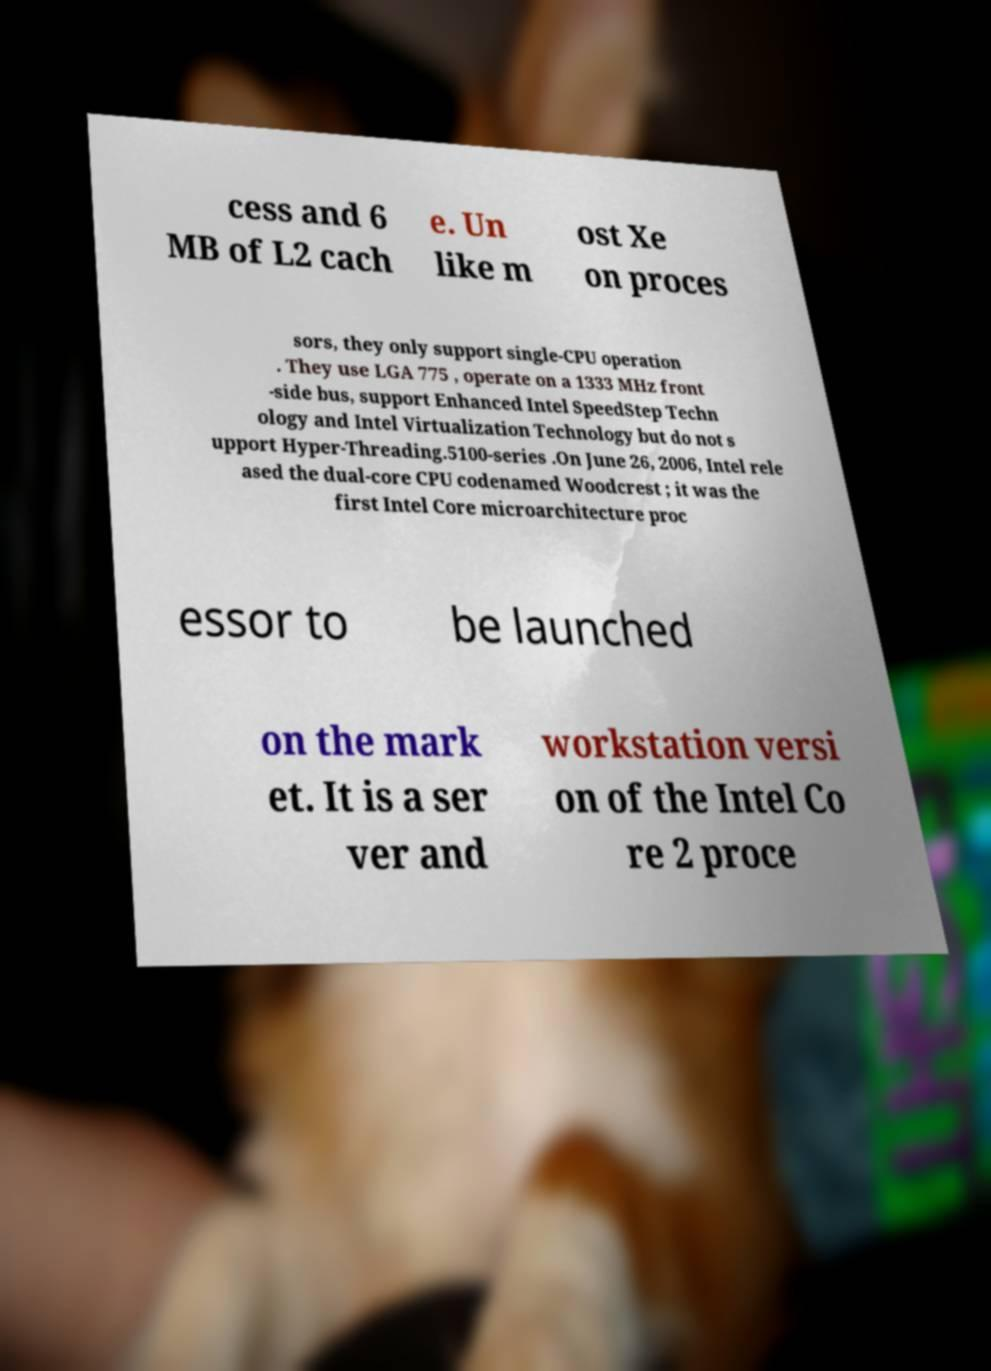For documentation purposes, I need the text within this image transcribed. Could you provide that? cess and 6 MB of L2 cach e. Un like m ost Xe on proces sors, they only support single-CPU operation . They use LGA 775 , operate on a 1333 MHz front -side bus, support Enhanced Intel SpeedStep Techn ology and Intel Virtualization Technology but do not s upport Hyper-Threading.5100-series .On June 26, 2006, Intel rele ased the dual-core CPU codenamed Woodcrest ; it was the first Intel Core microarchitecture proc essor to be launched on the mark et. It is a ser ver and workstation versi on of the Intel Co re 2 proce 